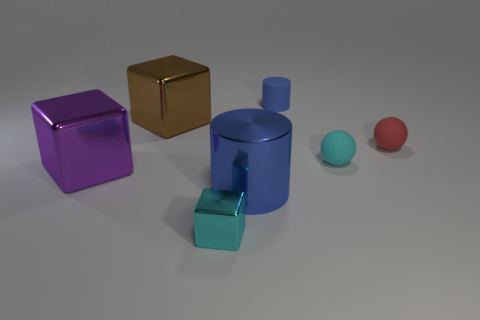Add 3 big cubes. How many objects exist? 10 Subtract all tiny cyan metal blocks. How many blocks are left? 2 Subtract all cyan cubes. How many cubes are left? 2 Subtract all cubes. How many objects are left? 4 Subtract 0 red cubes. How many objects are left? 7 Subtract 1 spheres. How many spheres are left? 1 Subtract all gray spheres. Subtract all cyan blocks. How many spheres are left? 2 Subtract all cyan cylinders. How many purple balls are left? 0 Subtract all small cyan blocks. Subtract all large cylinders. How many objects are left? 5 Add 7 blue shiny objects. How many blue shiny objects are left? 8 